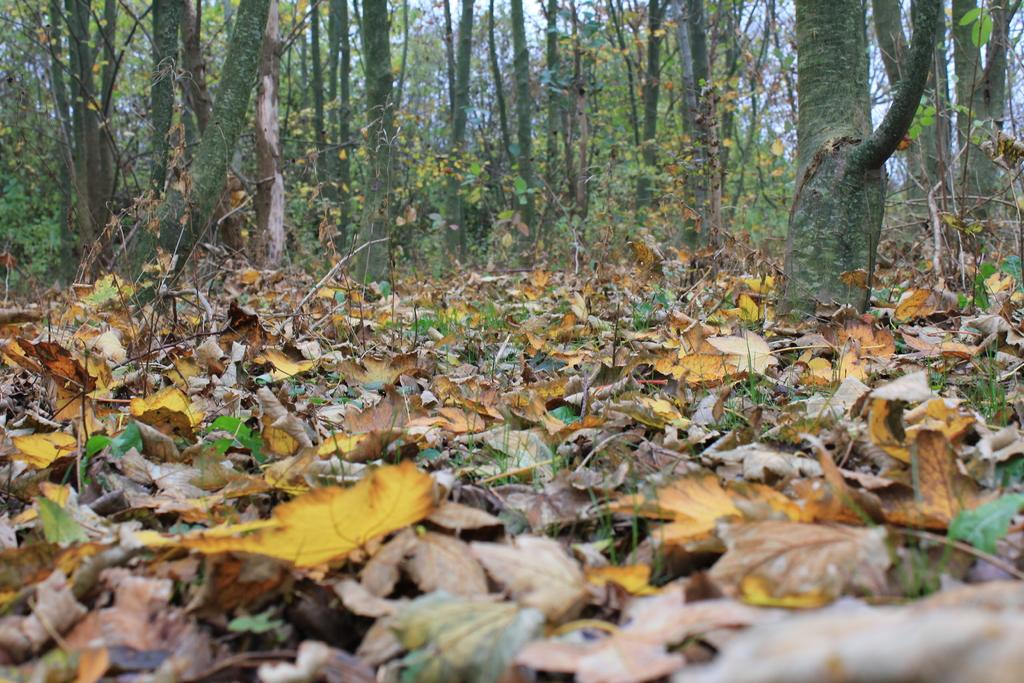What is covering the ground in the image? There are many dry leaves on the ground. What can be seen around the trees in the image? There are plenty of leaves around the trees. How many passengers are sitting on the doll in the image? There is no doll or passengers present in the image. 